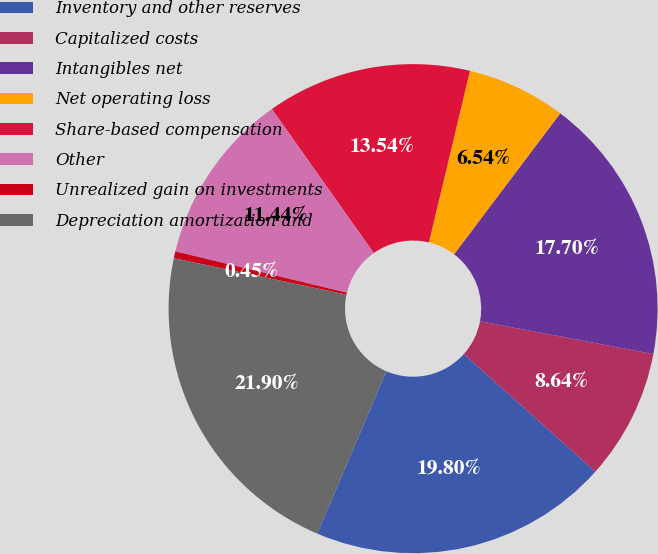<chart> <loc_0><loc_0><loc_500><loc_500><pie_chart><fcel>Inventory and other reserves<fcel>Capitalized costs<fcel>Intangibles net<fcel>Net operating loss<fcel>Share-based compensation<fcel>Other<fcel>Unrealized gain on investments<fcel>Depreciation amortization and<nl><fcel>19.8%<fcel>8.64%<fcel>17.7%<fcel>6.54%<fcel>13.54%<fcel>11.44%<fcel>0.45%<fcel>21.9%<nl></chart> 